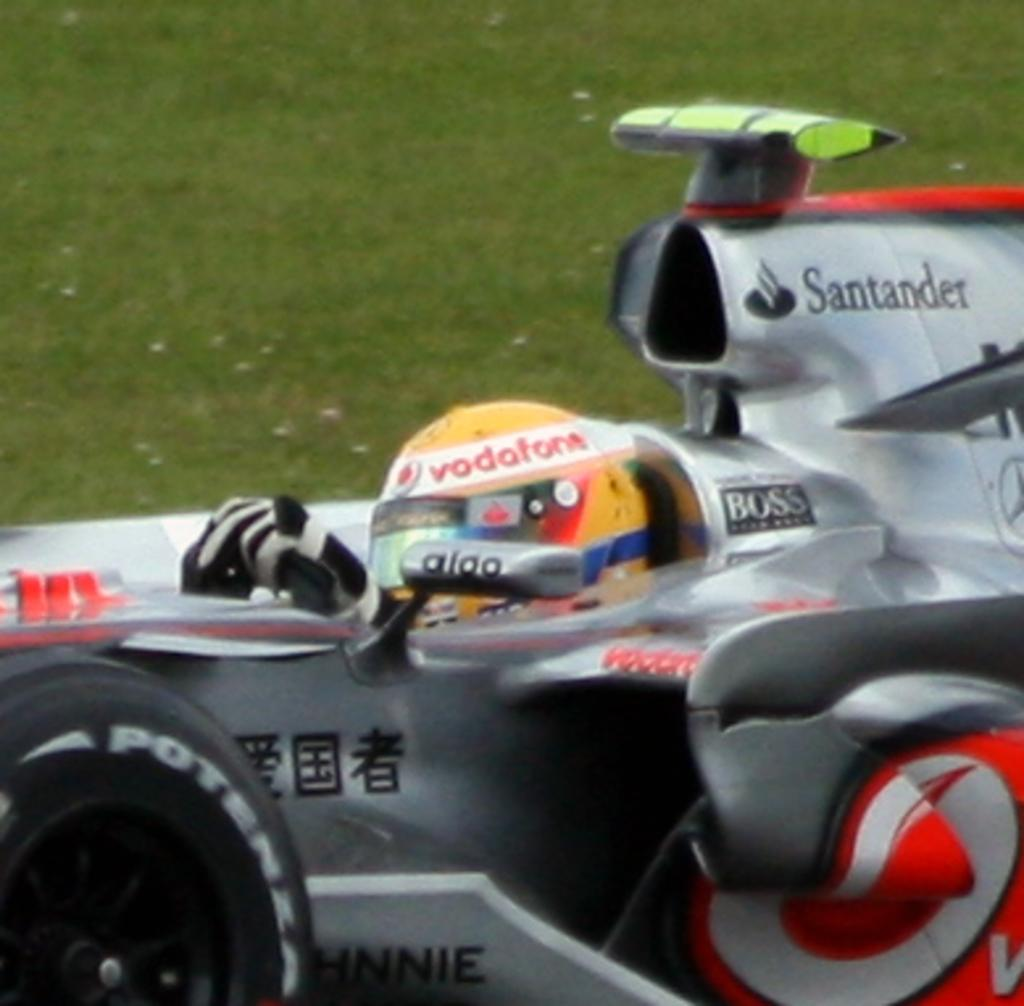<image>
Render a clear and concise summary of the photo. A motorized vehicle that says Boss and Santander. 